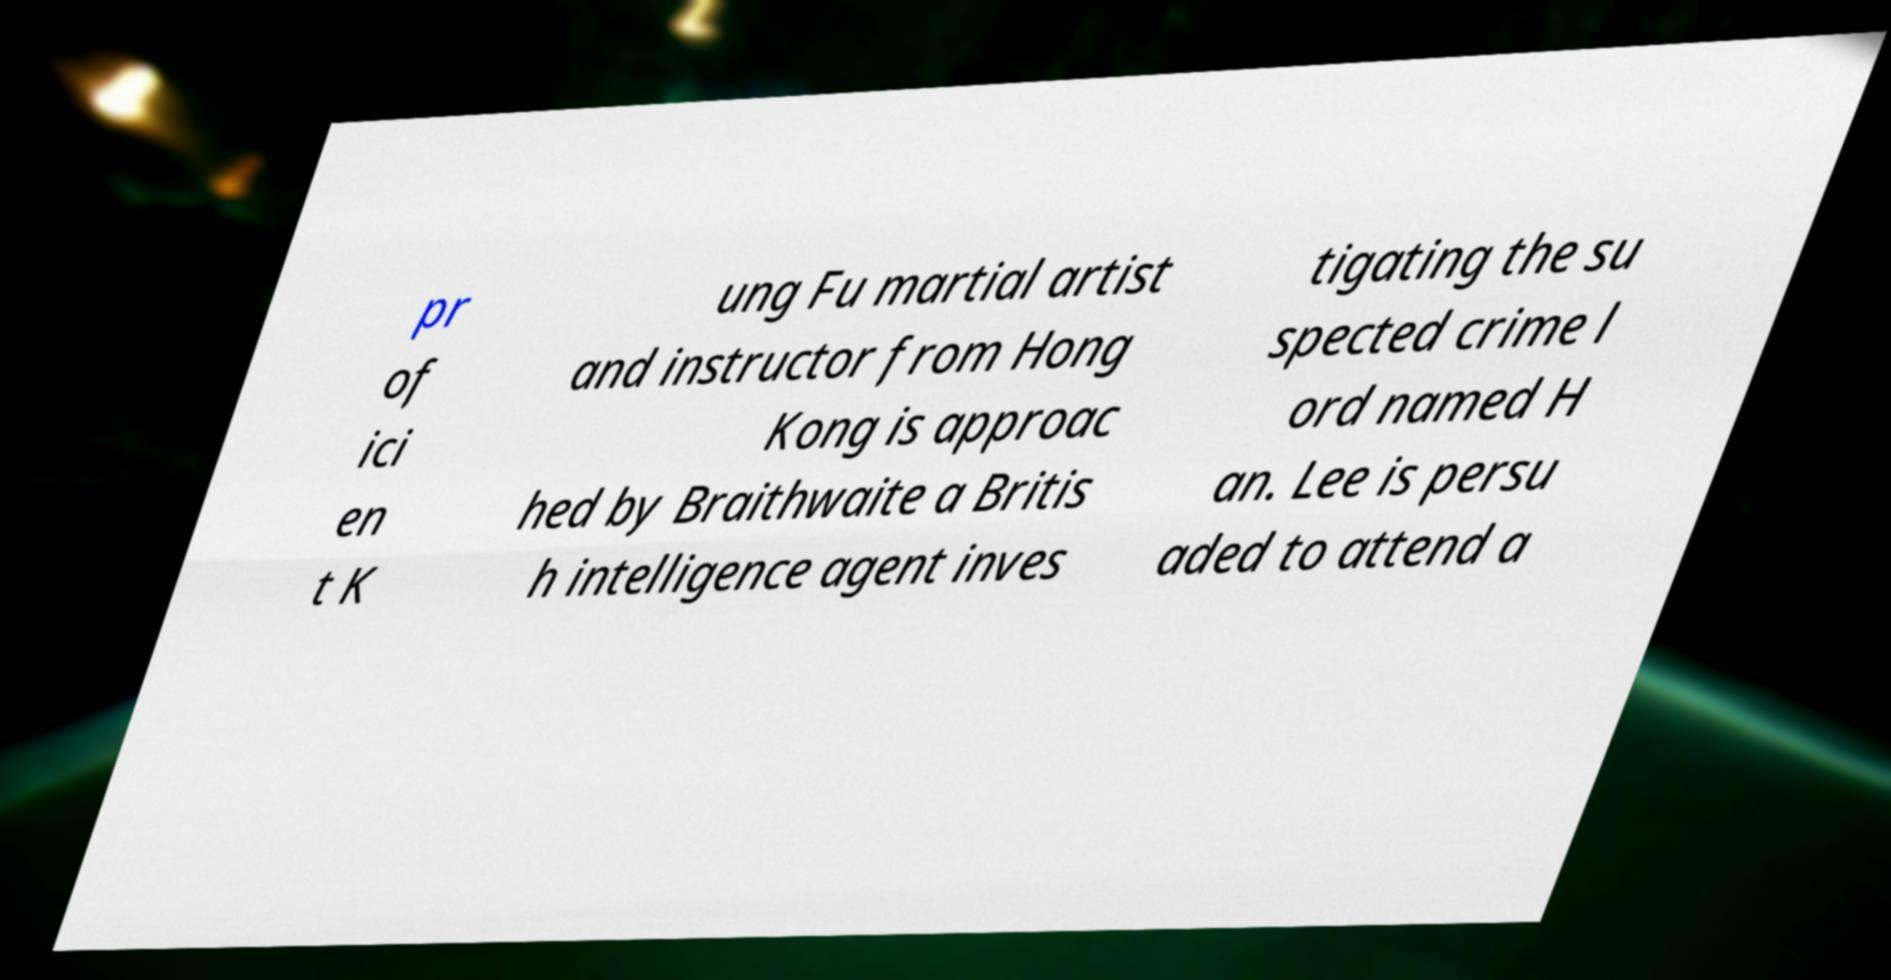I need the written content from this picture converted into text. Can you do that? pr of ici en t K ung Fu martial artist and instructor from Hong Kong is approac hed by Braithwaite a Britis h intelligence agent inves tigating the su spected crime l ord named H an. Lee is persu aded to attend a 